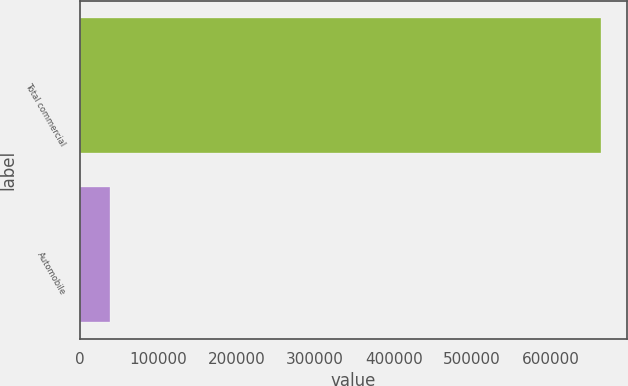Convert chart to OTSL. <chart><loc_0><loc_0><loc_500><loc_500><bar_chart><fcel>Total commercial<fcel>Automobile<nl><fcel>664073<fcel>38282<nl></chart> 